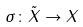<formula> <loc_0><loc_0><loc_500><loc_500>\sigma \colon \tilde { X } \rightarrow X</formula> 